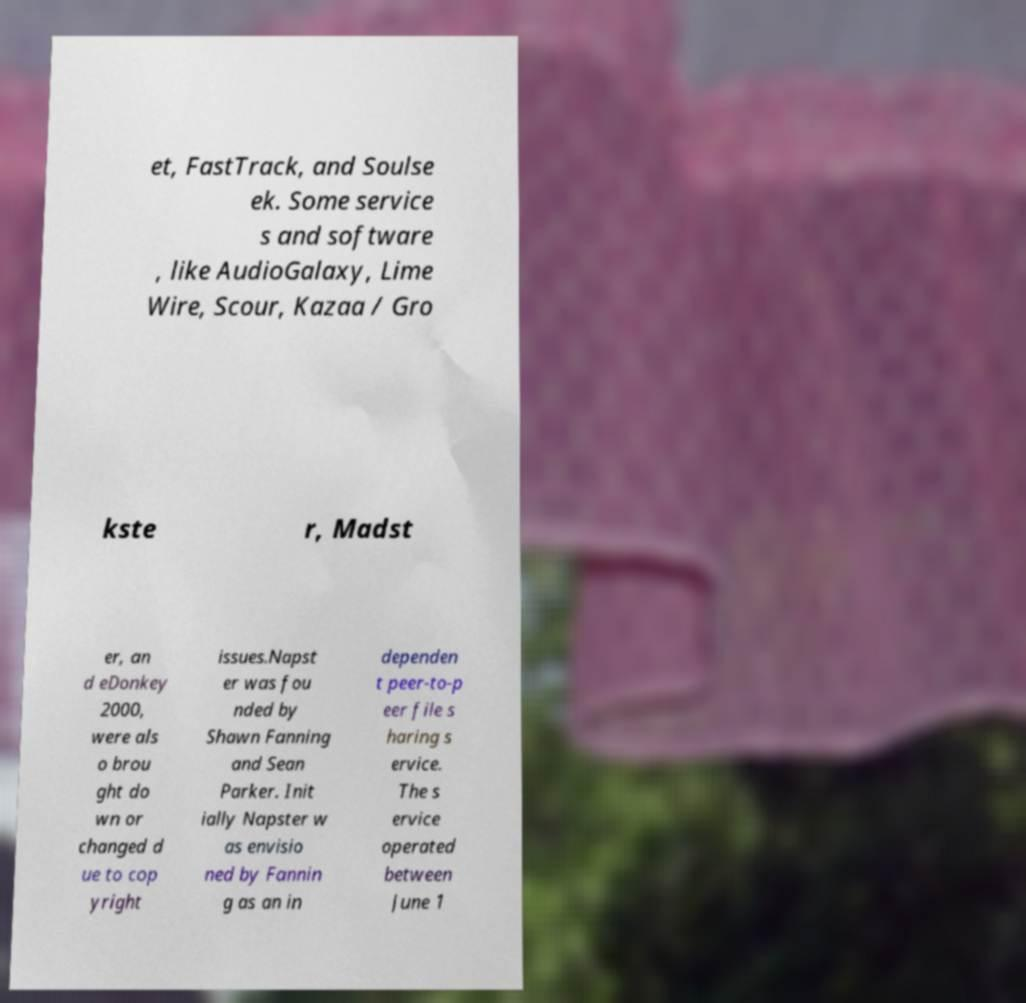Can you read and provide the text displayed in the image?This photo seems to have some interesting text. Can you extract and type it out for me? et, FastTrack, and Soulse ek. Some service s and software , like AudioGalaxy, Lime Wire, Scour, Kazaa / Gro kste r, Madst er, an d eDonkey 2000, were als o brou ght do wn or changed d ue to cop yright issues.Napst er was fou nded by Shawn Fanning and Sean Parker. Init ially Napster w as envisio ned by Fannin g as an in dependen t peer-to-p eer file s haring s ervice. The s ervice operated between June 1 